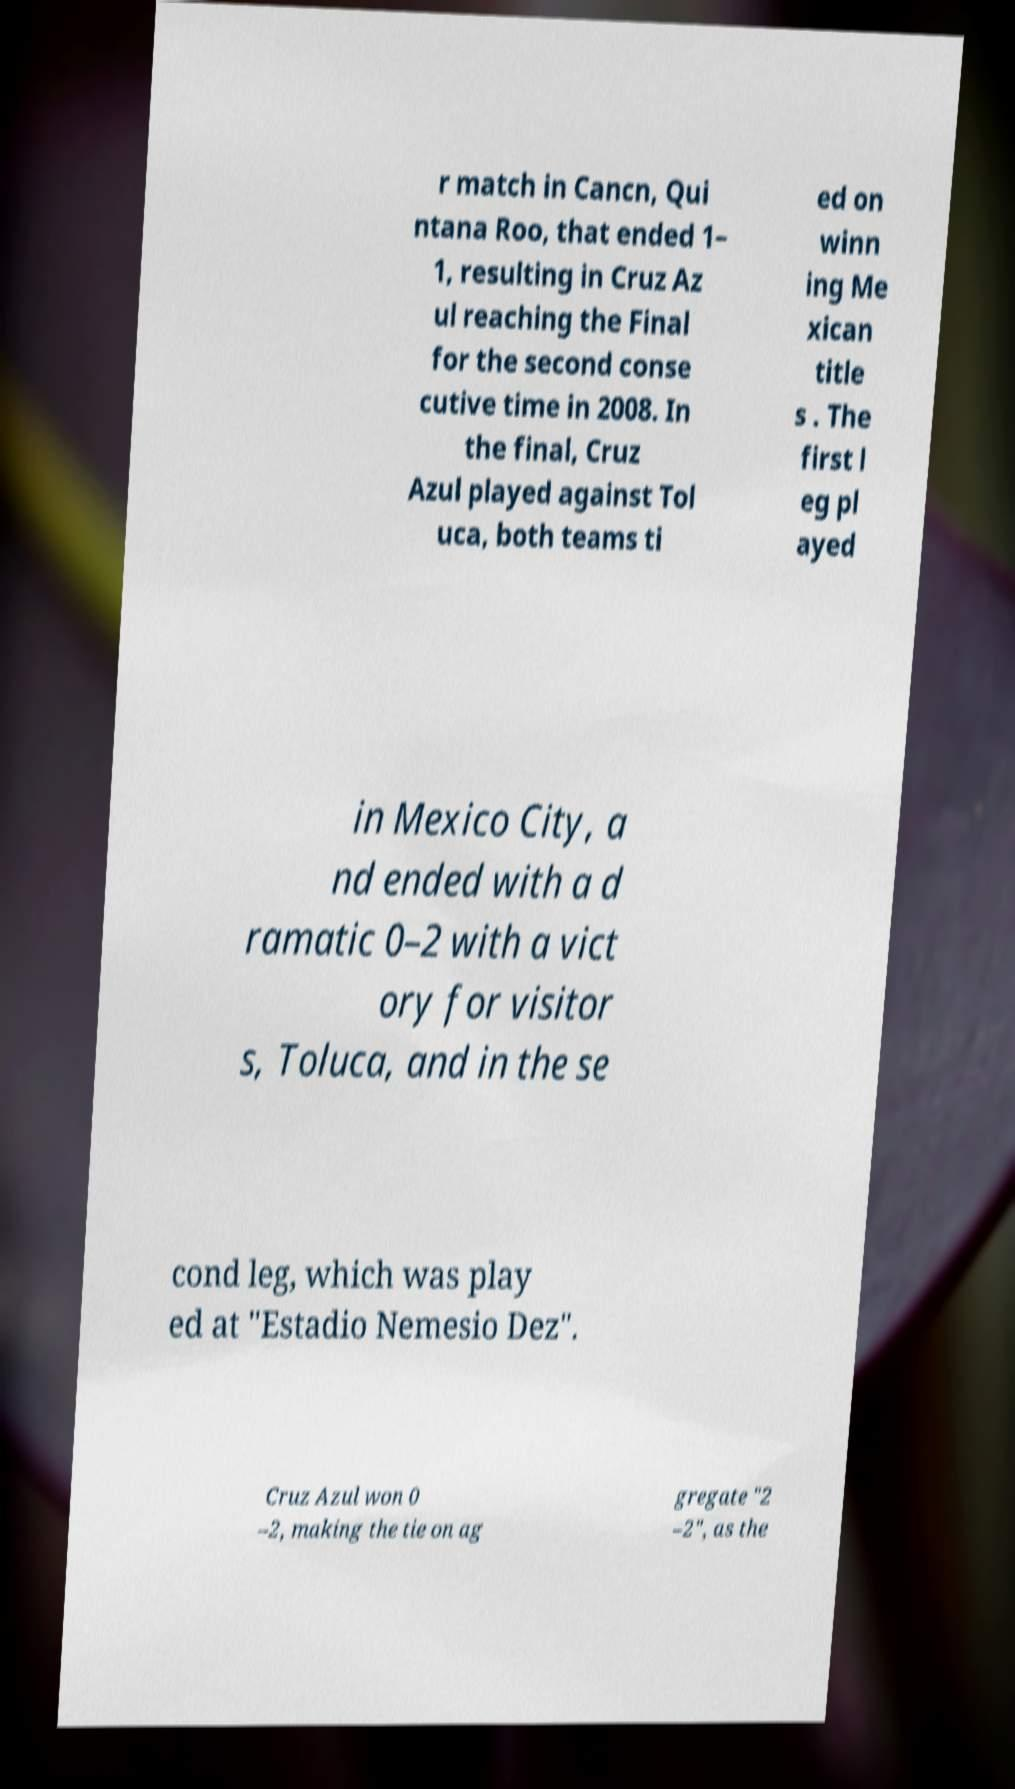Please identify and transcribe the text found in this image. r match in Cancn, Qui ntana Roo, that ended 1– 1, resulting in Cruz Az ul reaching the Final for the second conse cutive time in 2008. In the final, Cruz Azul played against Tol uca, both teams ti ed on winn ing Me xican title s . The first l eg pl ayed in Mexico City, a nd ended with a d ramatic 0–2 with a vict ory for visitor s, Toluca, and in the se cond leg, which was play ed at "Estadio Nemesio Dez". Cruz Azul won 0 –2, making the tie on ag gregate "2 –2", as the 